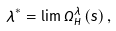Convert formula to latex. <formula><loc_0><loc_0><loc_500><loc_500>\lambda ^ { \ast } = \lim \Omega _ { H } ^ { \lambda } \left ( s \right ) ,</formula> 